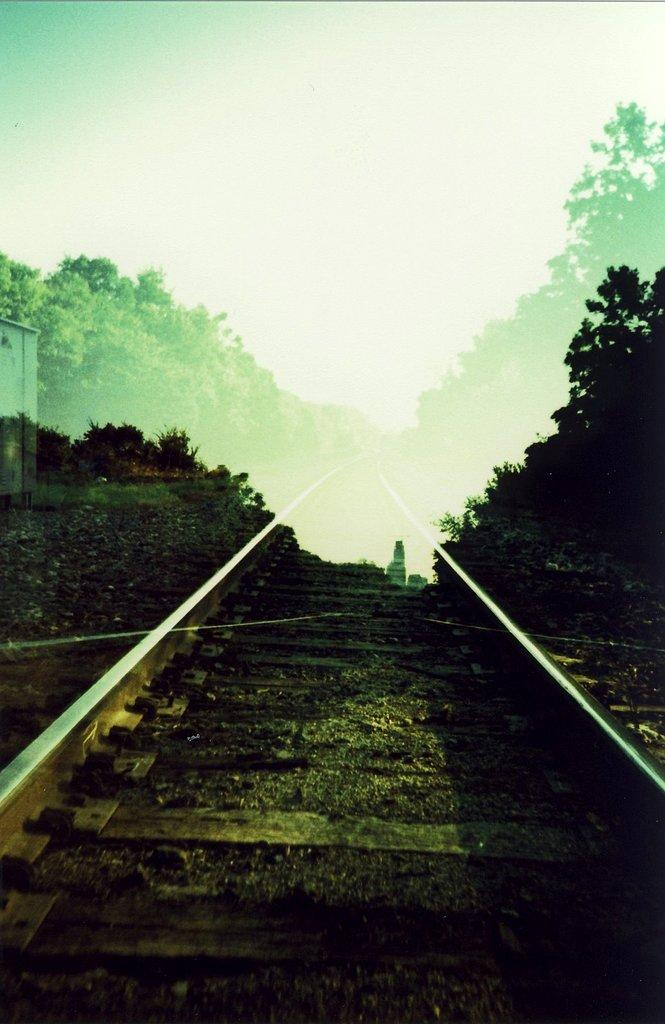What can be seen running through the path in the image? There is a railway track on the path in the image. What is present on both sides of the railway track? There are trees on the left side and the right side of the railway track. What does the writer observe while sitting on the path in the image? There is no writer present in the image, so it is impossible to determine what they might observe. 